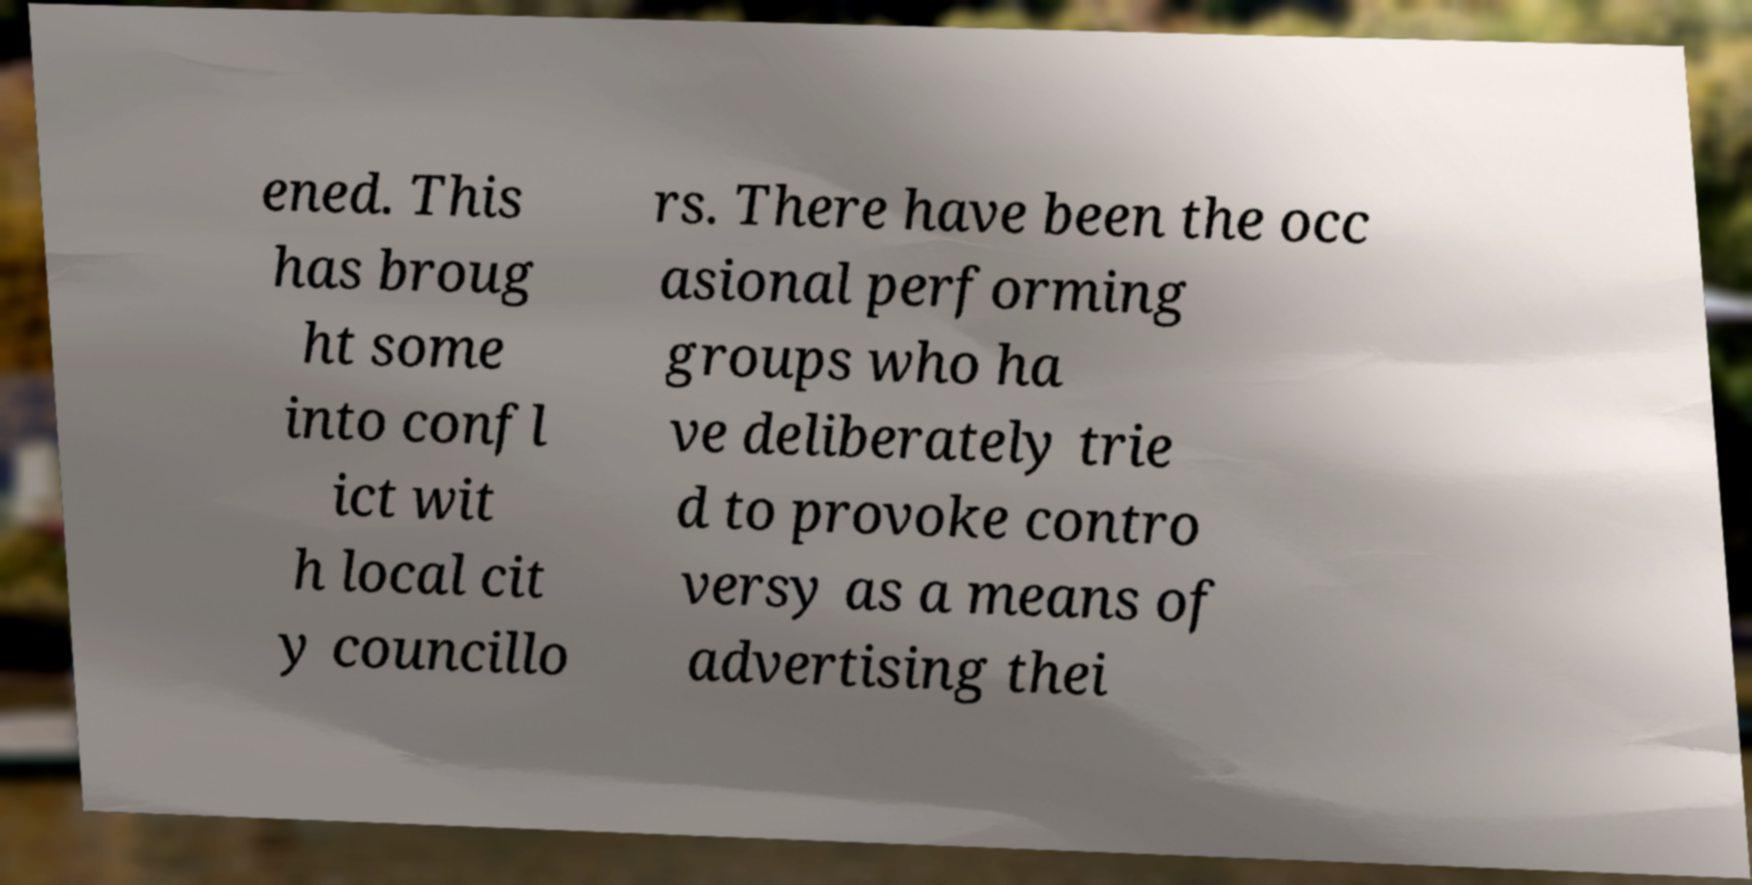I need the written content from this picture converted into text. Can you do that? ened. This has broug ht some into confl ict wit h local cit y councillo rs. There have been the occ asional performing groups who ha ve deliberately trie d to provoke contro versy as a means of advertising thei 